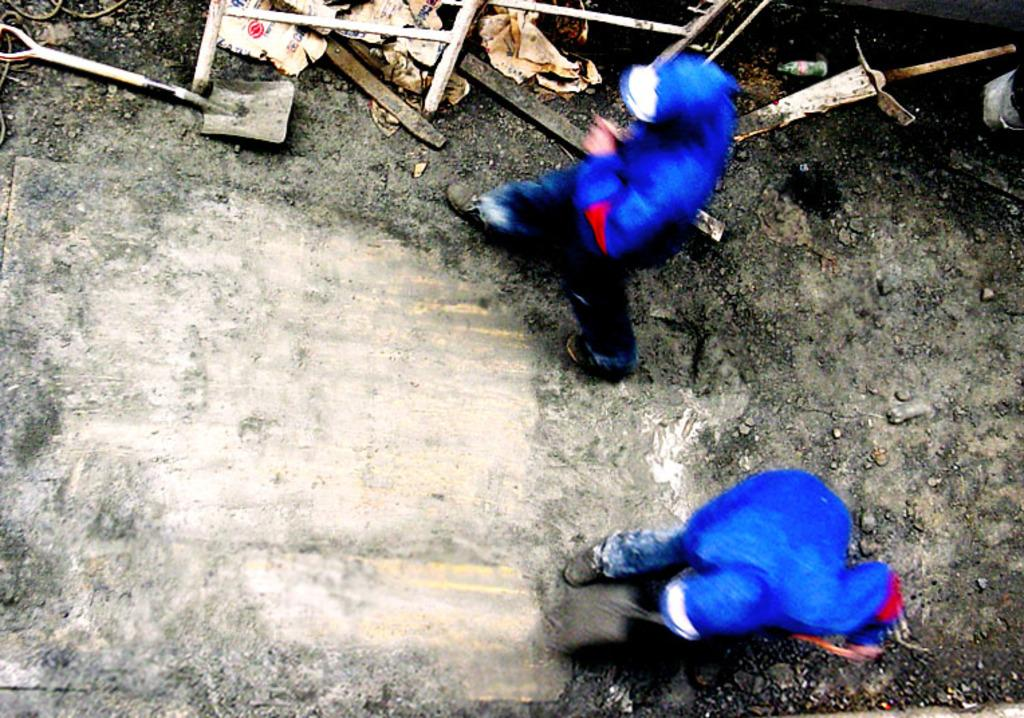How many people are in the image? There are two persons in the image. What are the people wearing in the image? Both persons are wearing blue jackets. What can be seen at the bottom of the image? There is a road visible at the bottom of the image. What is the manager's role in the image? There is no mention of a manager in the image, so it is not possible to determine their role. 